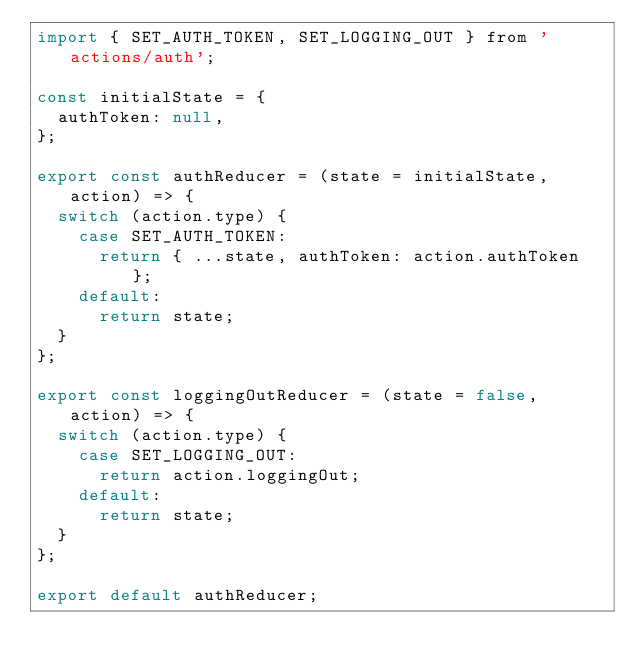<code> <loc_0><loc_0><loc_500><loc_500><_JavaScript_>import { SET_AUTH_TOKEN, SET_LOGGING_OUT } from 'actions/auth';

const initialState = {
  authToken: null,
};

export const authReducer = (state = initialState, action) => {
  switch (action.type) {
    case SET_AUTH_TOKEN:
      return { ...state, authToken: action.authToken };
    default:
      return state;
  }
};

export const loggingOutReducer = (state = false, action) => {
  switch (action.type) {
    case SET_LOGGING_OUT:
      return action.loggingOut;
    default:
      return state;
  }
};

export default authReducer;
</code> 